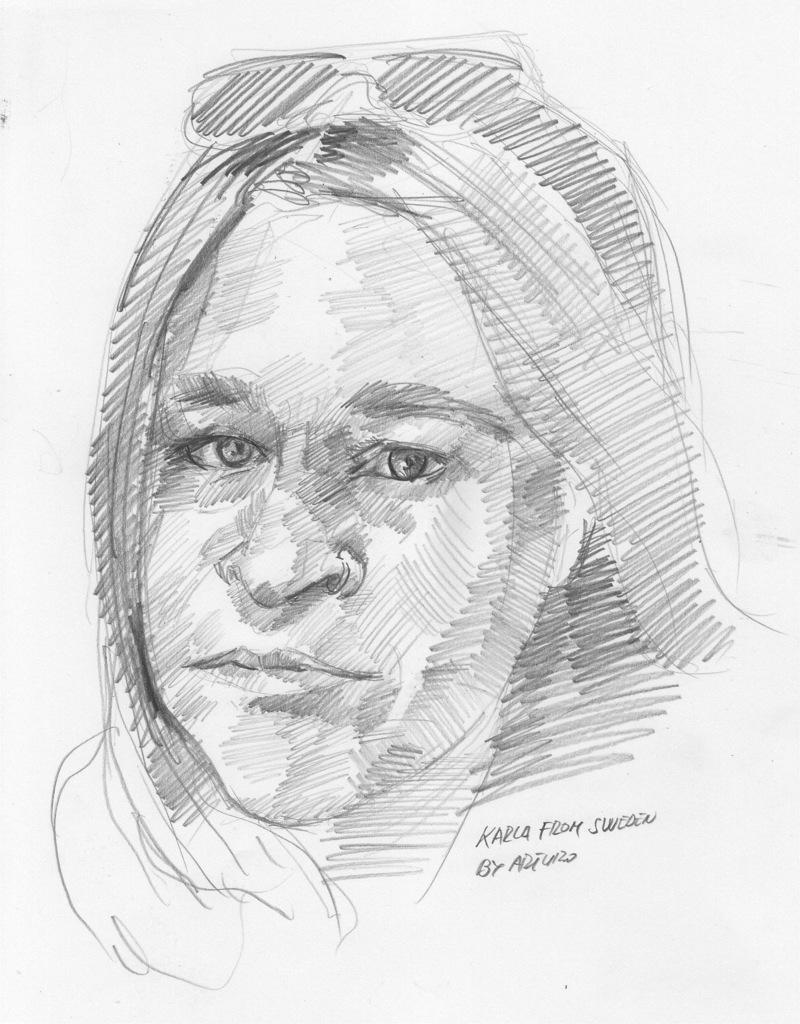Describe this image in one or two sentences. This image is a sketch. It is done on the paper with a pencil. 